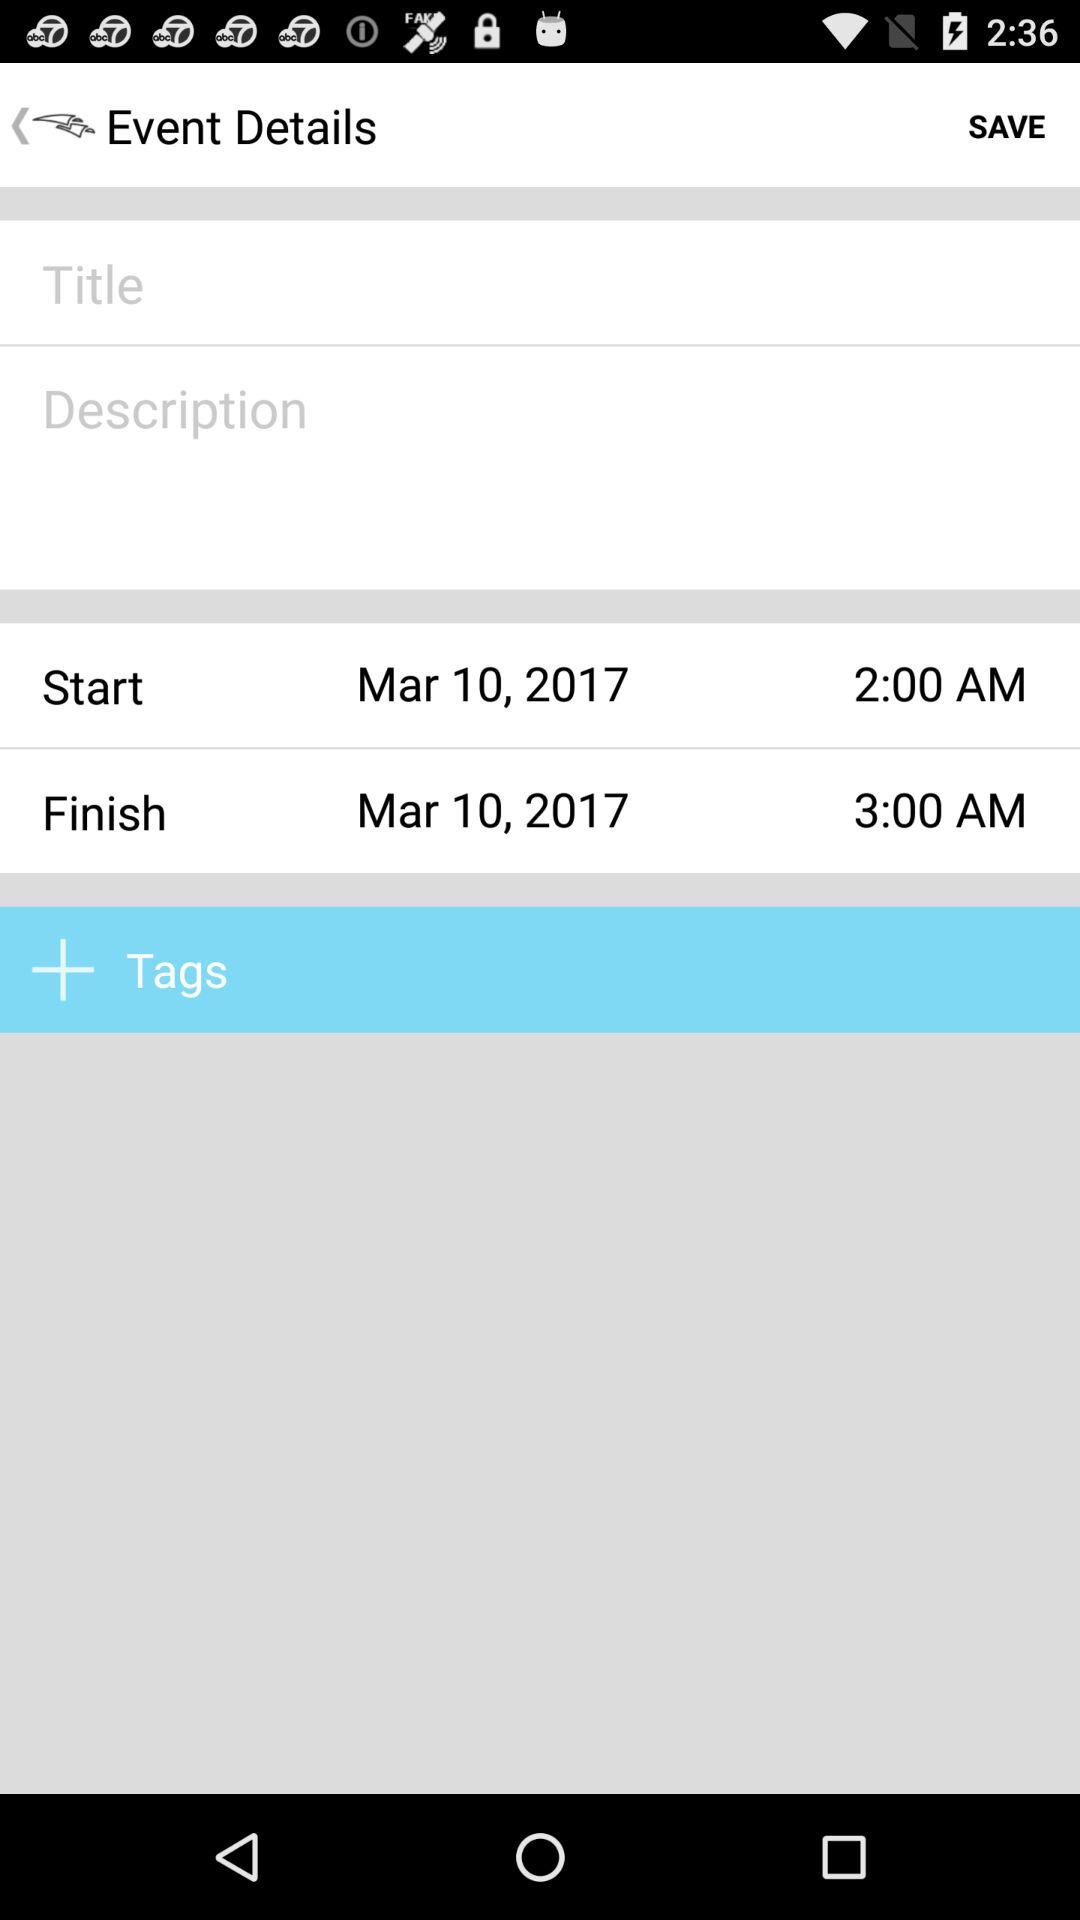What is the start time? The start time is 2:00 a.m. 